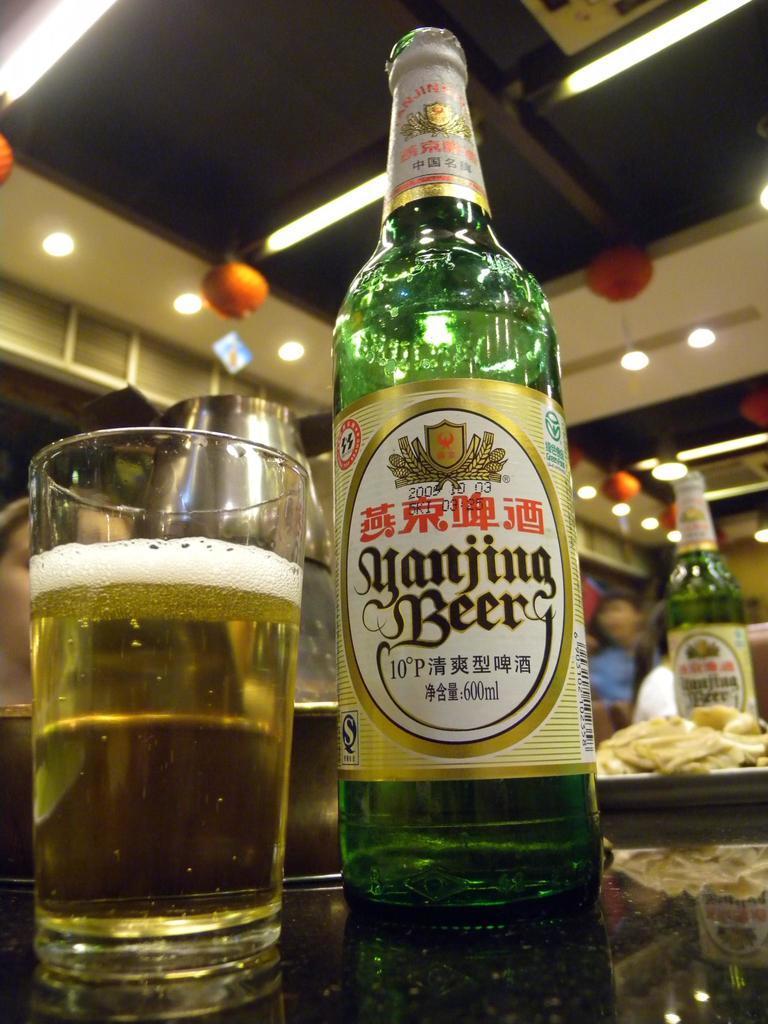In one or two sentences, can you explain what this image depicts? In this image I can see a bottle and a glass. 